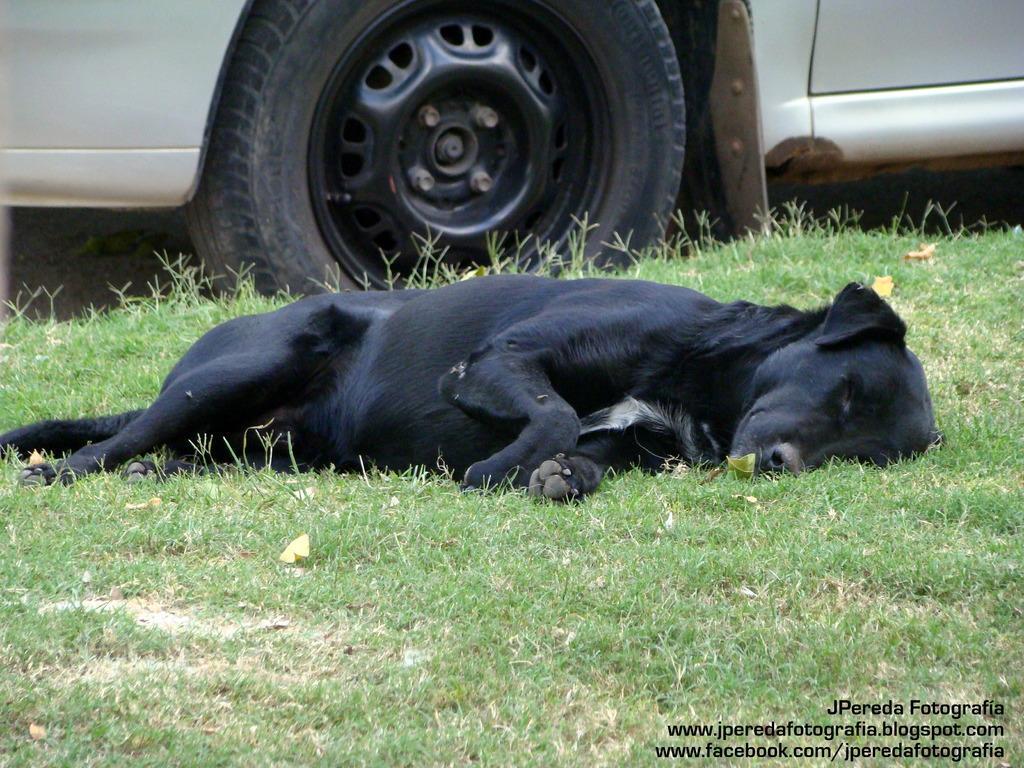Describe this image in one or two sentences. In the image we can see there is a dog lying on the ground and the ground is covered with grass and behind there is a car standing on the ground. 